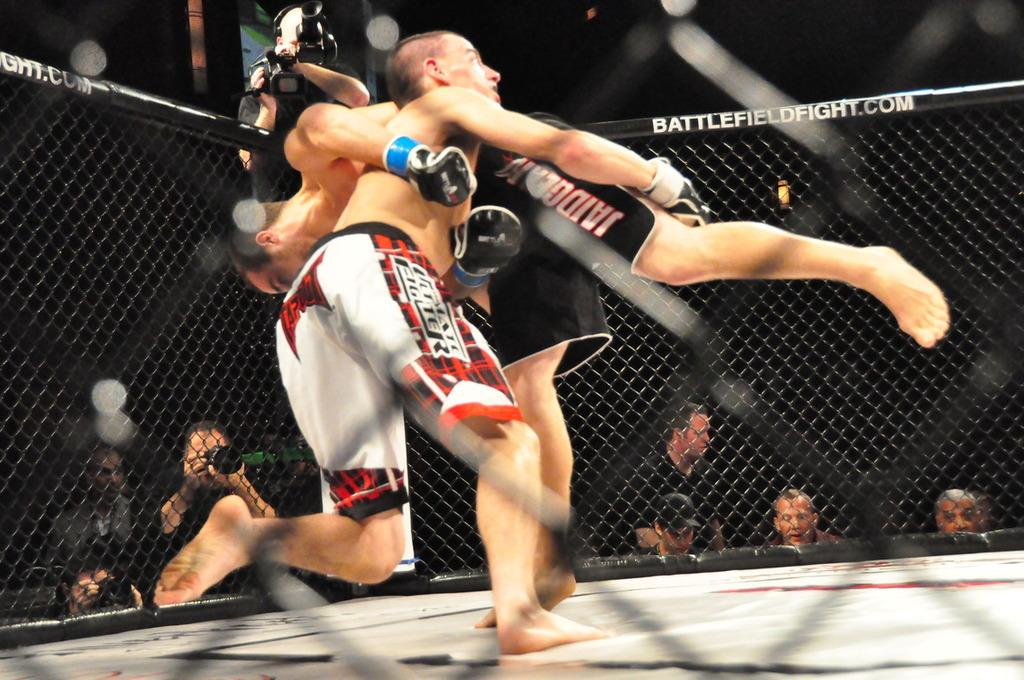What are the two persons in the image doing? The two persons in the image are wrestling. Where is the wrestling taking place? The wrestling is taking place on the ground. Can you describe the background of the image? There are persons in the background of the image, and a camera man is present. Additionally, there is fencing visible in the background. What type of pot is being used as evidence in the crime scene depicted in the image? There is no crime scene or pot present in the image; it features two persons wrestling on the ground. 